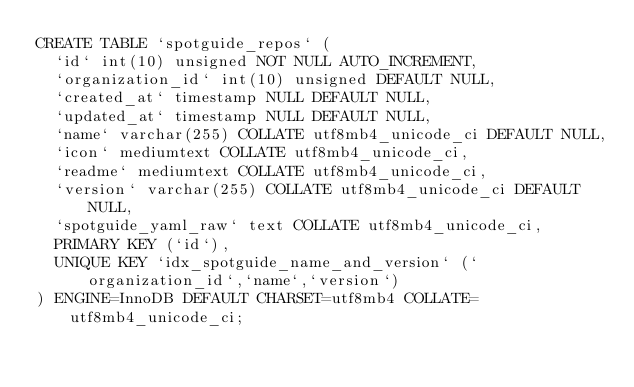Convert code to text. <code><loc_0><loc_0><loc_500><loc_500><_SQL_>CREATE TABLE `spotguide_repos` (
  `id` int(10) unsigned NOT NULL AUTO_INCREMENT,
  `organization_id` int(10) unsigned DEFAULT NULL,
  `created_at` timestamp NULL DEFAULT NULL,
  `updated_at` timestamp NULL DEFAULT NULL,
  `name` varchar(255) COLLATE utf8mb4_unicode_ci DEFAULT NULL,
  `icon` mediumtext COLLATE utf8mb4_unicode_ci,
  `readme` mediumtext COLLATE utf8mb4_unicode_ci,
  `version` varchar(255) COLLATE utf8mb4_unicode_ci DEFAULT NULL,
  `spotguide_yaml_raw` text COLLATE utf8mb4_unicode_ci,
  PRIMARY KEY (`id`),
  UNIQUE KEY `idx_spotguide_name_and_version` (`organization_id`,`name`,`version`)
) ENGINE=InnoDB DEFAULT CHARSET=utf8mb4 COLLATE=utf8mb4_unicode_ci;
</code> 